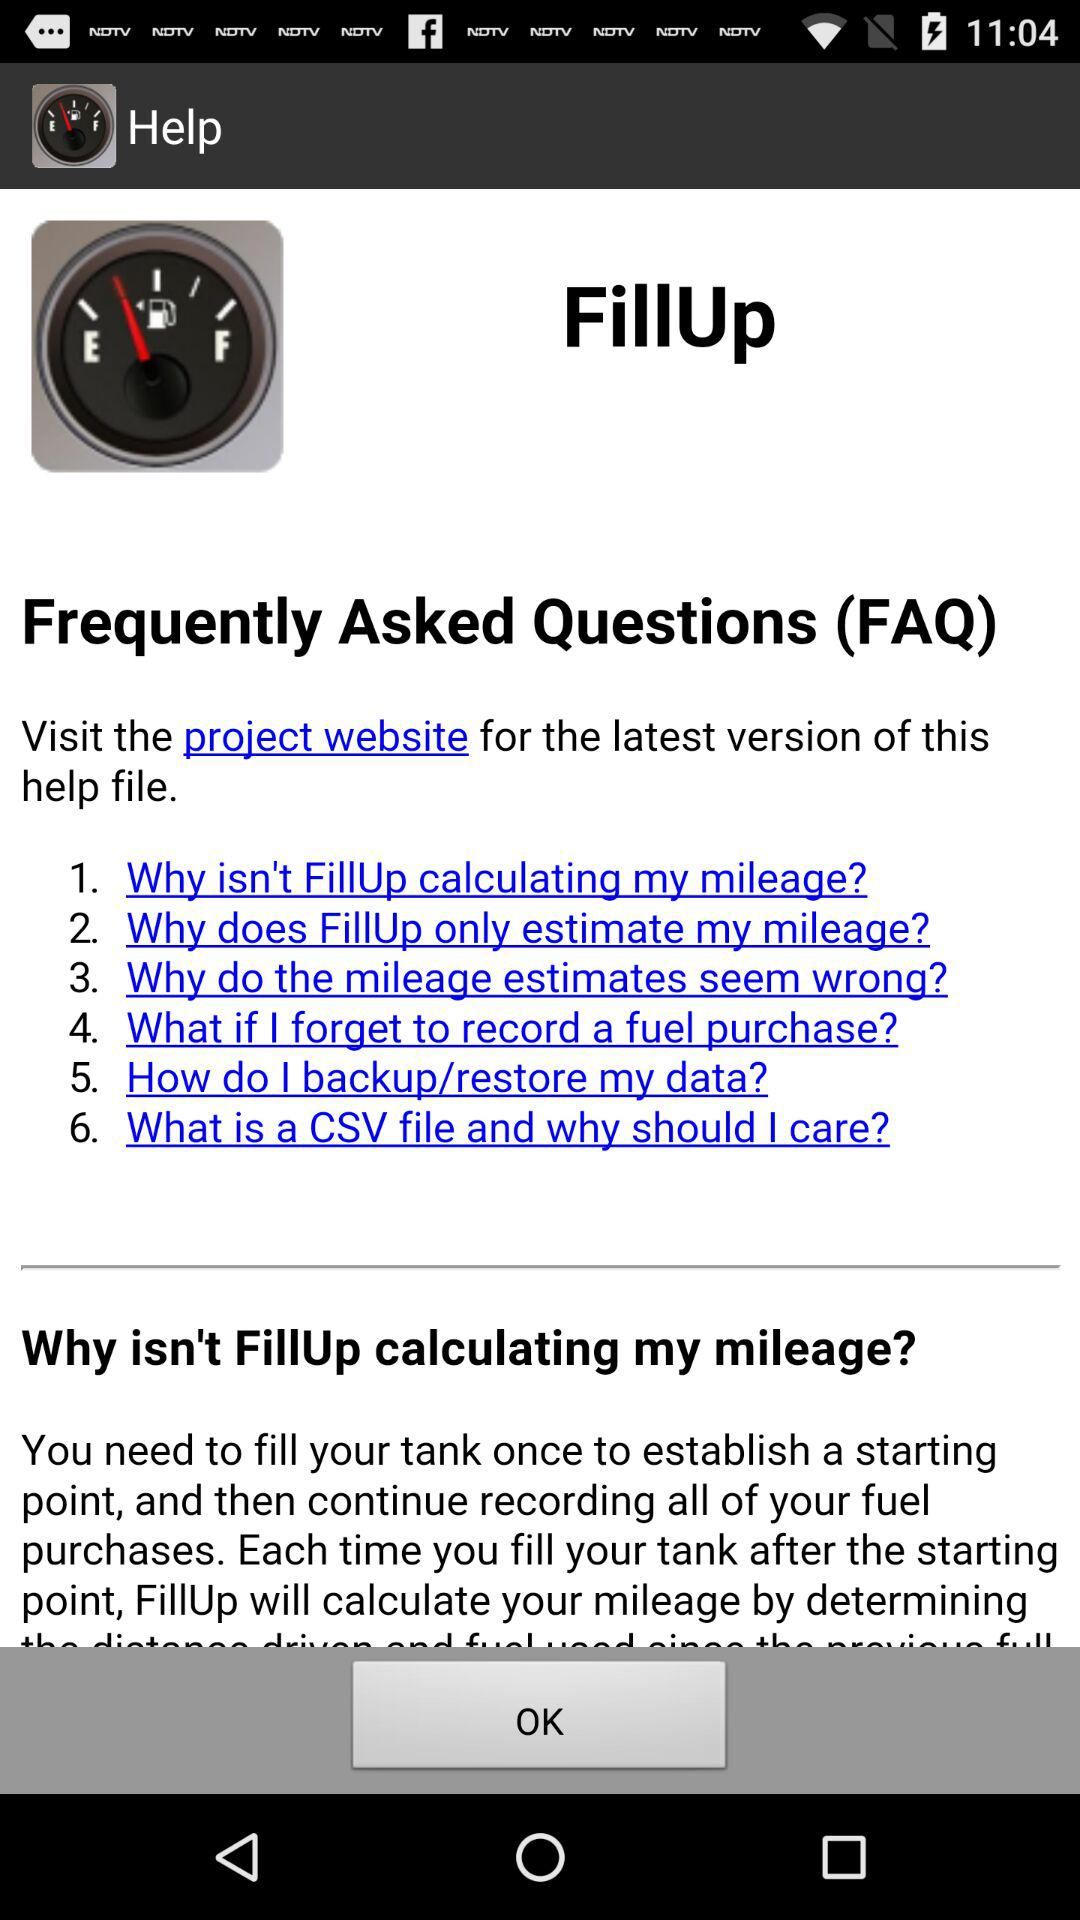What website do we visit for the latest version of this help file? You need to visit the project website for the latest version of this help file. 